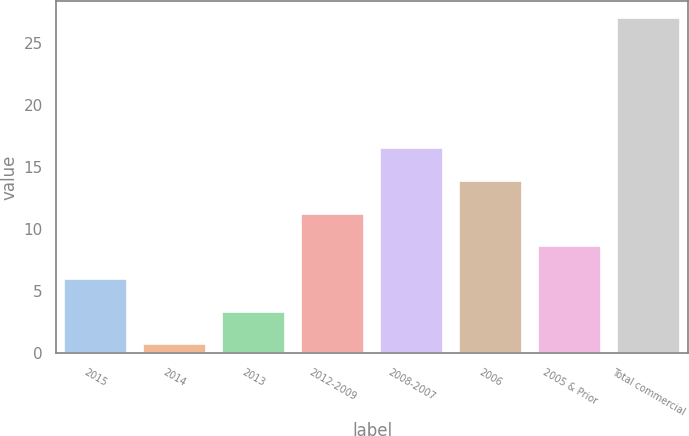<chart> <loc_0><loc_0><loc_500><loc_500><bar_chart><fcel>2015<fcel>2014<fcel>2013<fcel>2012-2009<fcel>2008-2007<fcel>2006<fcel>2005 & Prior<fcel>Total commercial<nl><fcel>5.99<fcel>0.73<fcel>3.36<fcel>11.25<fcel>16.51<fcel>13.88<fcel>8.62<fcel>27<nl></chart> 